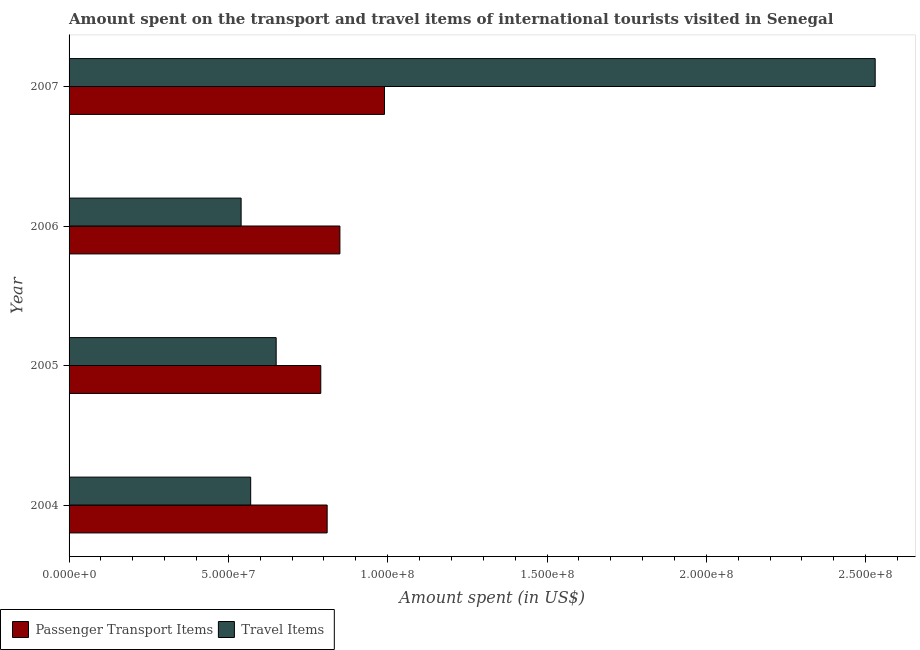Are the number of bars per tick equal to the number of legend labels?
Provide a short and direct response. Yes. What is the label of the 1st group of bars from the top?
Make the answer very short. 2007. What is the amount spent in travel items in 2005?
Provide a succinct answer. 6.50e+07. Across all years, what is the maximum amount spent in travel items?
Your answer should be very brief. 2.53e+08. Across all years, what is the minimum amount spent in travel items?
Your answer should be compact. 5.40e+07. What is the total amount spent in travel items in the graph?
Offer a terse response. 4.29e+08. What is the difference between the amount spent on passenger transport items in 2005 and that in 2007?
Provide a short and direct response. -2.00e+07. What is the difference between the amount spent on passenger transport items in 2006 and the amount spent in travel items in 2007?
Provide a succinct answer. -1.68e+08. What is the average amount spent on passenger transport items per year?
Keep it short and to the point. 8.60e+07. In the year 2005, what is the difference between the amount spent on passenger transport items and amount spent in travel items?
Make the answer very short. 1.40e+07. In how many years, is the amount spent in travel items greater than 230000000 US$?
Give a very brief answer. 1. Is the amount spent in travel items in 2004 less than that in 2006?
Ensure brevity in your answer.  No. Is the difference between the amount spent on passenger transport items in 2005 and 2006 greater than the difference between the amount spent in travel items in 2005 and 2006?
Keep it short and to the point. No. What is the difference between the highest and the second highest amount spent on passenger transport items?
Your answer should be very brief. 1.40e+07. What is the difference between the highest and the lowest amount spent in travel items?
Offer a very short reply. 1.99e+08. What does the 2nd bar from the top in 2007 represents?
Keep it short and to the point. Passenger Transport Items. What does the 2nd bar from the bottom in 2005 represents?
Provide a short and direct response. Travel Items. How many bars are there?
Provide a succinct answer. 8. Are all the bars in the graph horizontal?
Provide a succinct answer. Yes. Are the values on the major ticks of X-axis written in scientific E-notation?
Your response must be concise. Yes. Does the graph contain any zero values?
Make the answer very short. No. Does the graph contain grids?
Keep it short and to the point. No. How are the legend labels stacked?
Give a very brief answer. Horizontal. What is the title of the graph?
Keep it short and to the point. Amount spent on the transport and travel items of international tourists visited in Senegal. What is the label or title of the X-axis?
Make the answer very short. Amount spent (in US$). What is the label or title of the Y-axis?
Give a very brief answer. Year. What is the Amount spent (in US$) of Passenger Transport Items in 2004?
Your answer should be compact. 8.10e+07. What is the Amount spent (in US$) in Travel Items in 2004?
Make the answer very short. 5.70e+07. What is the Amount spent (in US$) in Passenger Transport Items in 2005?
Ensure brevity in your answer.  7.90e+07. What is the Amount spent (in US$) of Travel Items in 2005?
Give a very brief answer. 6.50e+07. What is the Amount spent (in US$) in Passenger Transport Items in 2006?
Ensure brevity in your answer.  8.50e+07. What is the Amount spent (in US$) in Travel Items in 2006?
Make the answer very short. 5.40e+07. What is the Amount spent (in US$) of Passenger Transport Items in 2007?
Ensure brevity in your answer.  9.90e+07. What is the Amount spent (in US$) in Travel Items in 2007?
Give a very brief answer. 2.53e+08. Across all years, what is the maximum Amount spent (in US$) in Passenger Transport Items?
Keep it short and to the point. 9.90e+07. Across all years, what is the maximum Amount spent (in US$) of Travel Items?
Your answer should be compact. 2.53e+08. Across all years, what is the minimum Amount spent (in US$) in Passenger Transport Items?
Your answer should be very brief. 7.90e+07. Across all years, what is the minimum Amount spent (in US$) of Travel Items?
Give a very brief answer. 5.40e+07. What is the total Amount spent (in US$) in Passenger Transport Items in the graph?
Offer a very short reply. 3.44e+08. What is the total Amount spent (in US$) in Travel Items in the graph?
Your answer should be compact. 4.29e+08. What is the difference between the Amount spent (in US$) of Travel Items in 2004 and that in 2005?
Give a very brief answer. -8.00e+06. What is the difference between the Amount spent (in US$) of Passenger Transport Items in 2004 and that in 2006?
Offer a very short reply. -4.00e+06. What is the difference between the Amount spent (in US$) of Passenger Transport Items in 2004 and that in 2007?
Offer a terse response. -1.80e+07. What is the difference between the Amount spent (in US$) in Travel Items in 2004 and that in 2007?
Offer a terse response. -1.96e+08. What is the difference between the Amount spent (in US$) in Passenger Transport Items in 2005 and that in 2006?
Ensure brevity in your answer.  -6.00e+06. What is the difference between the Amount spent (in US$) in Travel Items in 2005 and that in 2006?
Ensure brevity in your answer.  1.10e+07. What is the difference between the Amount spent (in US$) of Passenger Transport Items in 2005 and that in 2007?
Keep it short and to the point. -2.00e+07. What is the difference between the Amount spent (in US$) in Travel Items in 2005 and that in 2007?
Keep it short and to the point. -1.88e+08. What is the difference between the Amount spent (in US$) in Passenger Transport Items in 2006 and that in 2007?
Offer a very short reply. -1.40e+07. What is the difference between the Amount spent (in US$) in Travel Items in 2006 and that in 2007?
Give a very brief answer. -1.99e+08. What is the difference between the Amount spent (in US$) of Passenger Transport Items in 2004 and the Amount spent (in US$) of Travel Items in 2005?
Your response must be concise. 1.60e+07. What is the difference between the Amount spent (in US$) in Passenger Transport Items in 2004 and the Amount spent (in US$) in Travel Items in 2006?
Your answer should be compact. 2.70e+07. What is the difference between the Amount spent (in US$) of Passenger Transport Items in 2004 and the Amount spent (in US$) of Travel Items in 2007?
Offer a terse response. -1.72e+08. What is the difference between the Amount spent (in US$) in Passenger Transport Items in 2005 and the Amount spent (in US$) in Travel Items in 2006?
Your answer should be compact. 2.50e+07. What is the difference between the Amount spent (in US$) of Passenger Transport Items in 2005 and the Amount spent (in US$) of Travel Items in 2007?
Provide a succinct answer. -1.74e+08. What is the difference between the Amount spent (in US$) in Passenger Transport Items in 2006 and the Amount spent (in US$) in Travel Items in 2007?
Offer a very short reply. -1.68e+08. What is the average Amount spent (in US$) in Passenger Transport Items per year?
Offer a terse response. 8.60e+07. What is the average Amount spent (in US$) of Travel Items per year?
Offer a terse response. 1.07e+08. In the year 2004, what is the difference between the Amount spent (in US$) in Passenger Transport Items and Amount spent (in US$) in Travel Items?
Make the answer very short. 2.40e+07. In the year 2005, what is the difference between the Amount spent (in US$) of Passenger Transport Items and Amount spent (in US$) of Travel Items?
Ensure brevity in your answer.  1.40e+07. In the year 2006, what is the difference between the Amount spent (in US$) in Passenger Transport Items and Amount spent (in US$) in Travel Items?
Offer a very short reply. 3.10e+07. In the year 2007, what is the difference between the Amount spent (in US$) of Passenger Transport Items and Amount spent (in US$) of Travel Items?
Keep it short and to the point. -1.54e+08. What is the ratio of the Amount spent (in US$) of Passenger Transport Items in 2004 to that in 2005?
Offer a very short reply. 1.03. What is the ratio of the Amount spent (in US$) of Travel Items in 2004 to that in 2005?
Your answer should be very brief. 0.88. What is the ratio of the Amount spent (in US$) in Passenger Transport Items in 2004 to that in 2006?
Provide a succinct answer. 0.95. What is the ratio of the Amount spent (in US$) in Travel Items in 2004 to that in 2006?
Keep it short and to the point. 1.06. What is the ratio of the Amount spent (in US$) in Passenger Transport Items in 2004 to that in 2007?
Provide a short and direct response. 0.82. What is the ratio of the Amount spent (in US$) in Travel Items in 2004 to that in 2007?
Your response must be concise. 0.23. What is the ratio of the Amount spent (in US$) in Passenger Transport Items in 2005 to that in 2006?
Keep it short and to the point. 0.93. What is the ratio of the Amount spent (in US$) in Travel Items in 2005 to that in 2006?
Make the answer very short. 1.2. What is the ratio of the Amount spent (in US$) in Passenger Transport Items in 2005 to that in 2007?
Your answer should be very brief. 0.8. What is the ratio of the Amount spent (in US$) in Travel Items in 2005 to that in 2007?
Provide a succinct answer. 0.26. What is the ratio of the Amount spent (in US$) in Passenger Transport Items in 2006 to that in 2007?
Offer a very short reply. 0.86. What is the ratio of the Amount spent (in US$) in Travel Items in 2006 to that in 2007?
Offer a terse response. 0.21. What is the difference between the highest and the second highest Amount spent (in US$) of Passenger Transport Items?
Your answer should be very brief. 1.40e+07. What is the difference between the highest and the second highest Amount spent (in US$) of Travel Items?
Your answer should be compact. 1.88e+08. What is the difference between the highest and the lowest Amount spent (in US$) of Passenger Transport Items?
Provide a succinct answer. 2.00e+07. What is the difference between the highest and the lowest Amount spent (in US$) in Travel Items?
Give a very brief answer. 1.99e+08. 